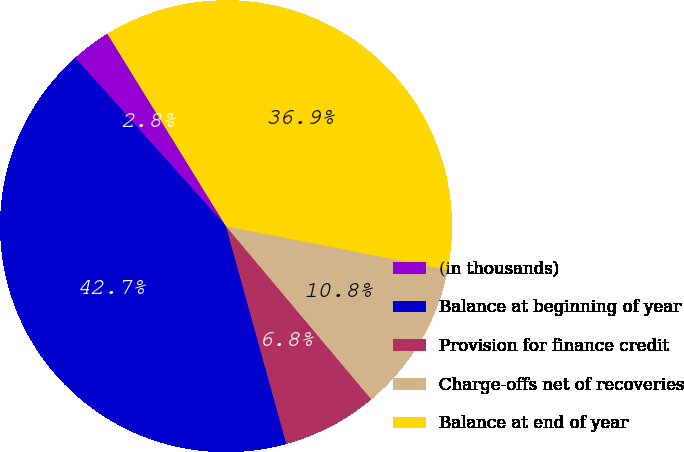<chart> <loc_0><loc_0><loc_500><loc_500><pie_chart><fcel>(in thousands)<fcel>Balance at beginning of year<fcel>Provision for finance credit<fcel>Charge-offs net of recoveries<fcel>Balance at end of year<nl><fcel>2.83%<fcel>42.68%<fcel>6.81%<fcel>10.8%<fcel>36.88%<nl></chart> 